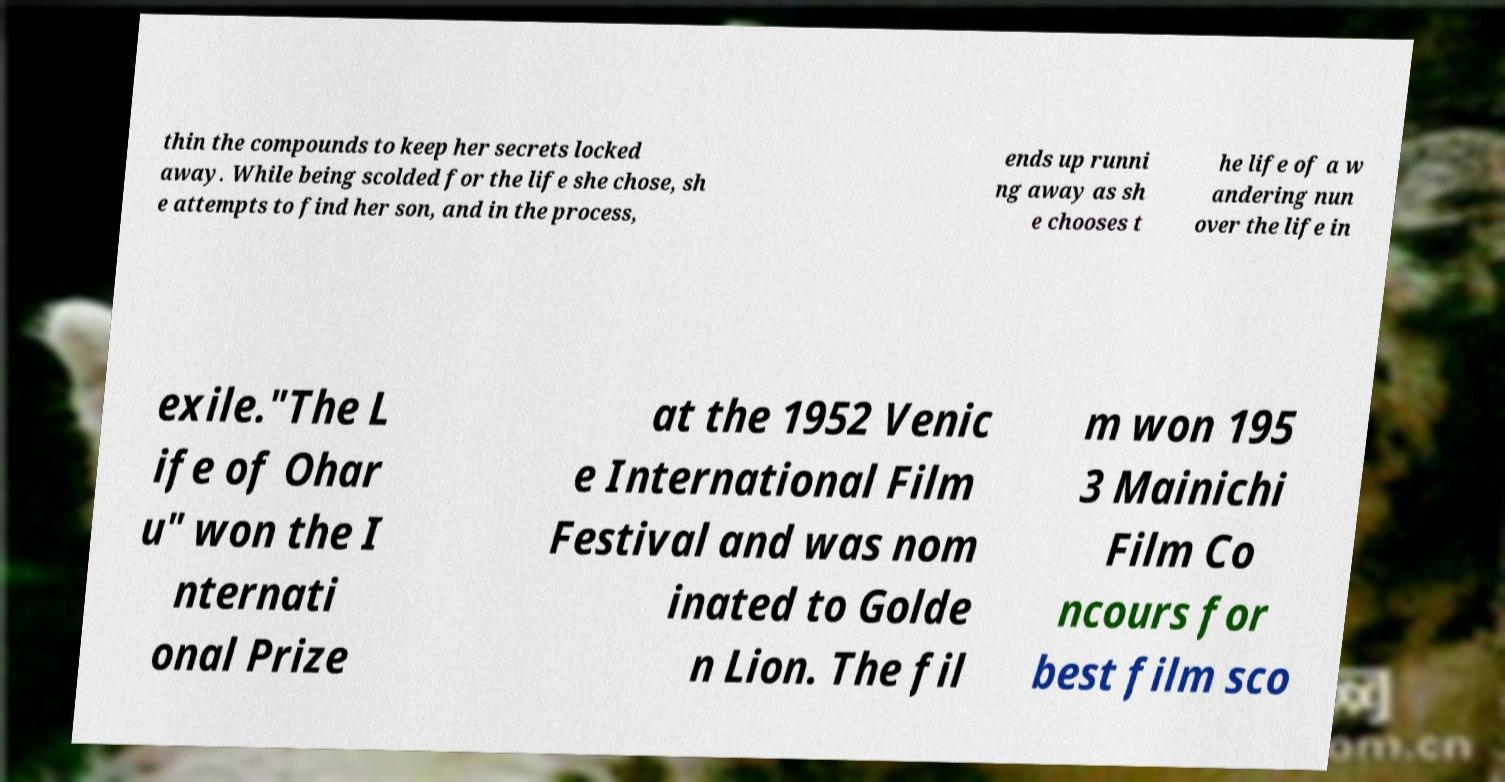Could you extract and type out the text from this image? thin the compounds to keep her secrets locked away. While being scolded for the life she chose, sh e attempts to find her son, and in the process, ends up runni ng away as sh e chooses t he life of a w andering nun over the life in exile."The L ife of Ohar u" won the I nternati onal Prize at the 1952 Venic e International Film Festival and was nom inated to Golde n Lion. The fil m won 195 3 Mainichi Film Co ncours for best film sco 